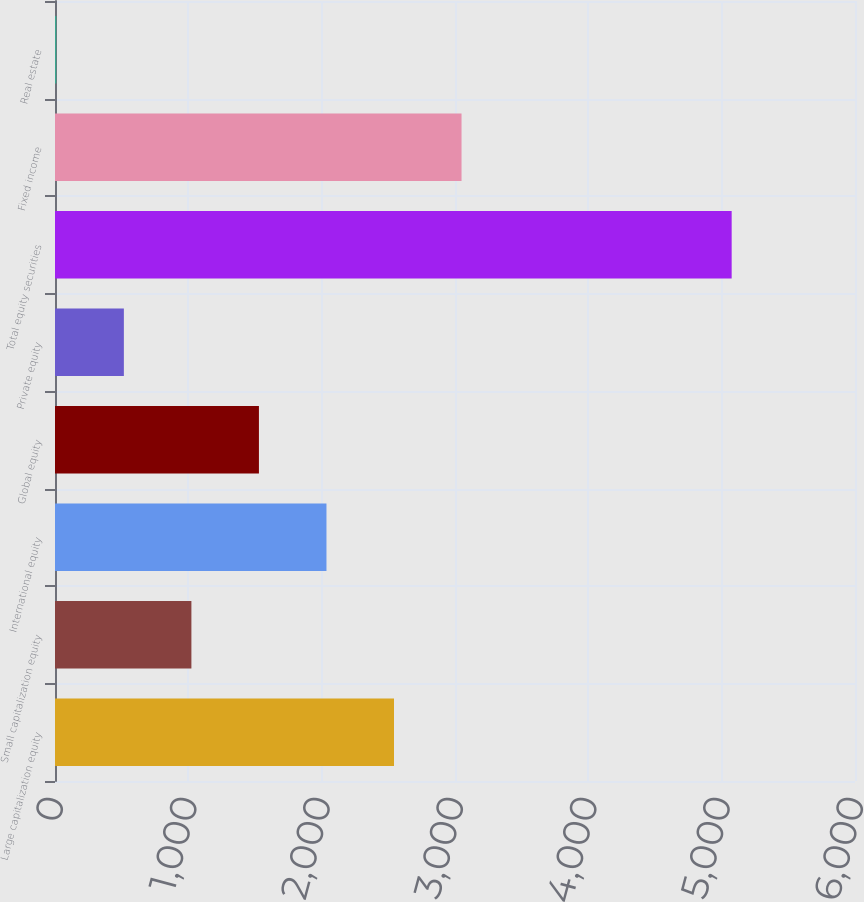Convert chart to OTSL. <chart><loc_0><loc_0><loc_500><loc_500><bar_chart><fcel>Large capitalization equity<fcel>Small capitalization equity<fcel>International equity<fcel>Global equity<fcel>Private equity<fcel>Total equity securities<fcel>Fixed income<fcel>Real estate<nl><fcel>2542.5<fcel>1023<fcel>2036<fcel>1529.5<fcel>516.5<fcel>5075<fcel>3049<fcel>10<nl></chart> 